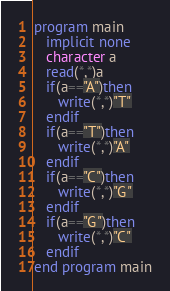Convert code to text. <code><loc_0><loc_0><loc_500><loc_500><_FORTRAN_>program main
   implicit none
   character a
   read(*,*)a
   if(a=="A")then
      write(*,*)"T"
   endif
   if(a=="T")then
      write(*,*)"A"
   endif
   if(a=="C")then
      write(*,*)"G"
   endif
   if(a=="G")then 
      write(*,*)"C"
   endif
end program main
</code> 